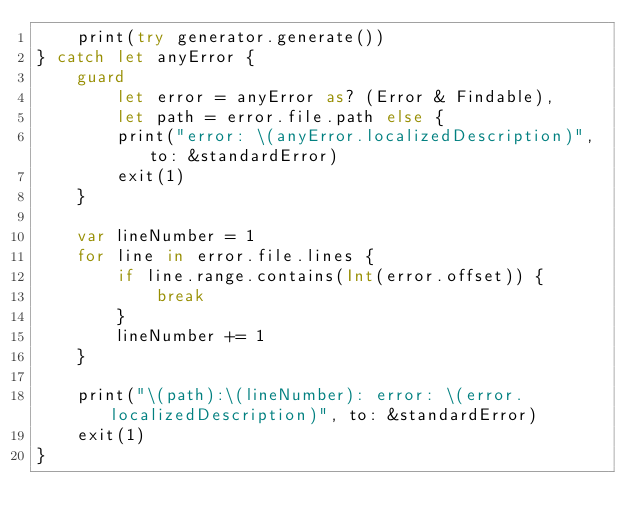<code> <loc_0><loc_0><loc_500><loc_500><_Swift_>    print(try generator.generate())
} catch let anyError {
    guard
        let error = anyError as? (Error & Findable),
        let path = error.file.path else {
        print("error: \(anyError.localizedDescription)", to: &standardError)
        exit(1)
    }

    var lineNumber = 1
    for line in error.file.lines {
        if line.range.contains(Int(error.offset)) {
            break
        }
        lineNumber += 1
    }

    print("\(path):\(lineNumber): error: \(error.localizedDescription)", to: &standardError)
    exit(1)
}
</code> 